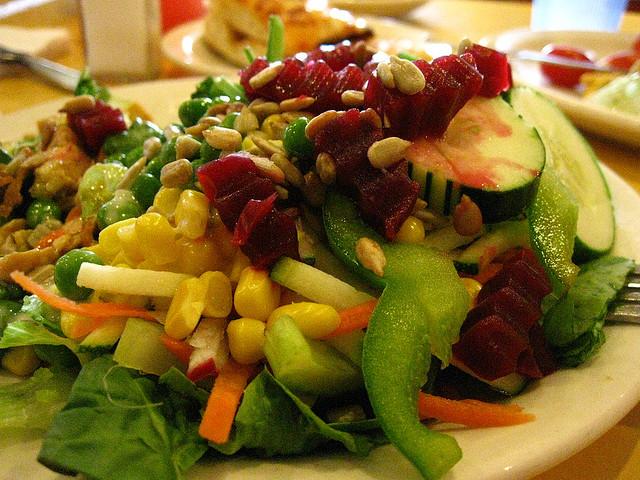What color is the plate?
Write a very short answer. White. Is this a sandwich?
Answer briefly. No. Is there any identifiable meat in this dish?
Write a very short answer. No. What are the yellow items in this dish?
Be succinct. Corn. 